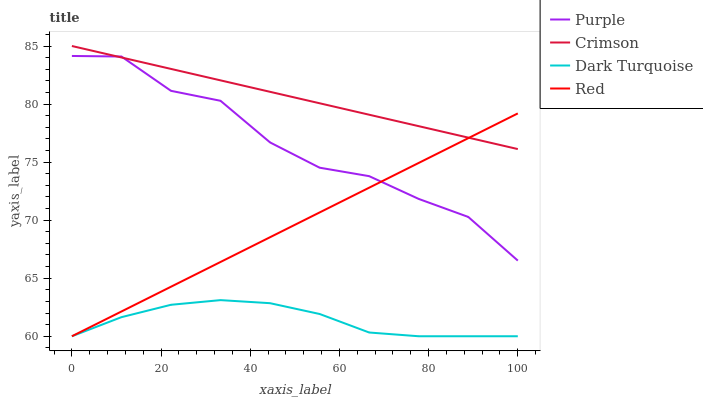Does Dark Turquoise have the minimum area under the curve?
Answer yes or no. Yes. Does Crimson have the maximum area under the curve?
Answer yes or no. Yes. Does Red have the minimum area under the curve?
Answer yes or no. No. Does Red have the maximum area under the curve?
Answer yes or no. No. Is Crimson the smoothest?
Answer yes or no. Yes. Is Purple the roughest?
Answer yes or no. Yes. Is Red the smoothest?
Answer yes or no. No. Is Red the roughest?
Answer yes or no. No. Does Red have the lowest value?
Answer yes or no. Yes. Does Crimson have the lowest value?
Answer yes or no. No. Does Crimson have the highest value?
Answer yes or no. Yes. Does Red have the highest value?
Answer yes or no. No. Is Dark Turquoise less than Crimson?
Answer yes or no. Yes. Is Crimson greater than Dark Turquoise?
Answer yes or no. Yes. Does Dark Turquoise intersect Red?
Answer yes or no. Yes. Is Dark Turquoise less than Red?
Answer yes or no. No. Is Dark Turquoise greater than Red?
Answer yes or no. No. Does Dark Turquoise intersect Crimson?
Answer yes or no. No. 